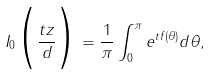<formula> <loc_0><loc_0><loc_500><loc_500>I _ { 0 } \Big { ( } \frac { t z } { d } \Big { ) } = \frac { 1 } { \pi } \int _ { 0 } ^ { \pi } e ^ { t f ( \theta ) } d \theta ,</formula> 